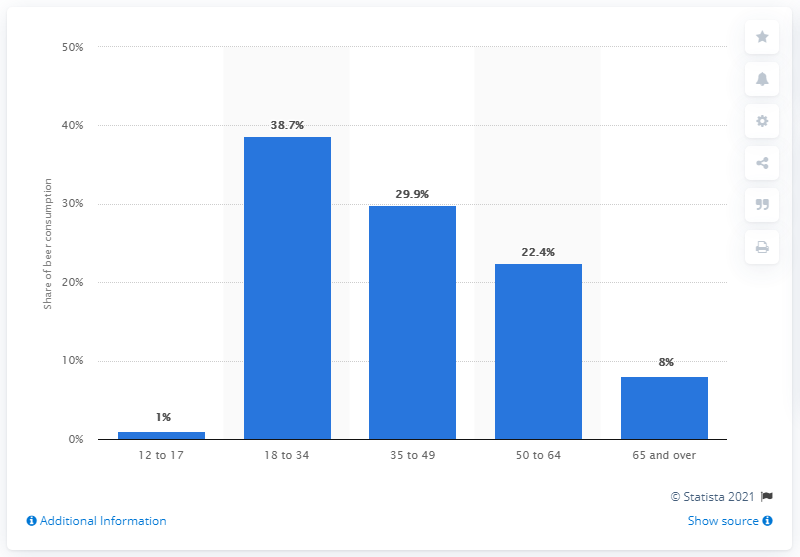Identify some key points in this picture. According to data, 29.9% of all beer sold in Canada was consumed by Canadians between the ages of 35 and 49 in a specific year. 